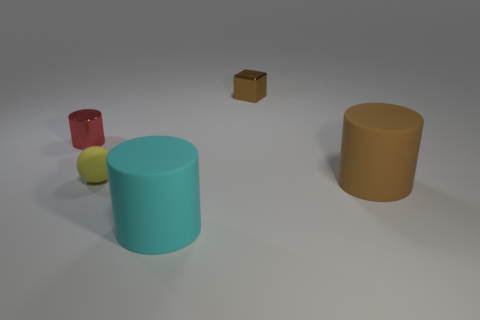Add 3 brown objects. How many objects exist? 8 Subtract all cylinders. How many objects are left? 2 Add 4 big red metal cubes. How many big red metal cubes exist? 4 Subtract 1 brown blocks. How many objects are left? 4 Subtract all large green objects. Subtract all brown cylinders. How many objects are left? 4 Add 3 spheres. How many spheres are left? 4 